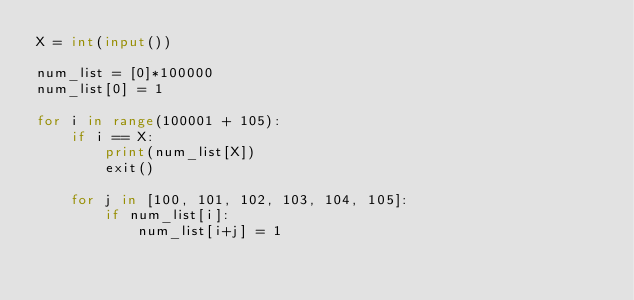<code> <loc_0><loc_0><loc_500><loc_500><_Python_>X = int(input())

num_list = [0]*100000
num_list[0] = 1

for i in range(100001 + 105):
    if i == X:
        print(num_list[X])
        exit()

    for j in [100, 101, 102, 103, 104, 105]:
        if num_list[i]:
            num_list[i+j] = 1
</code> 